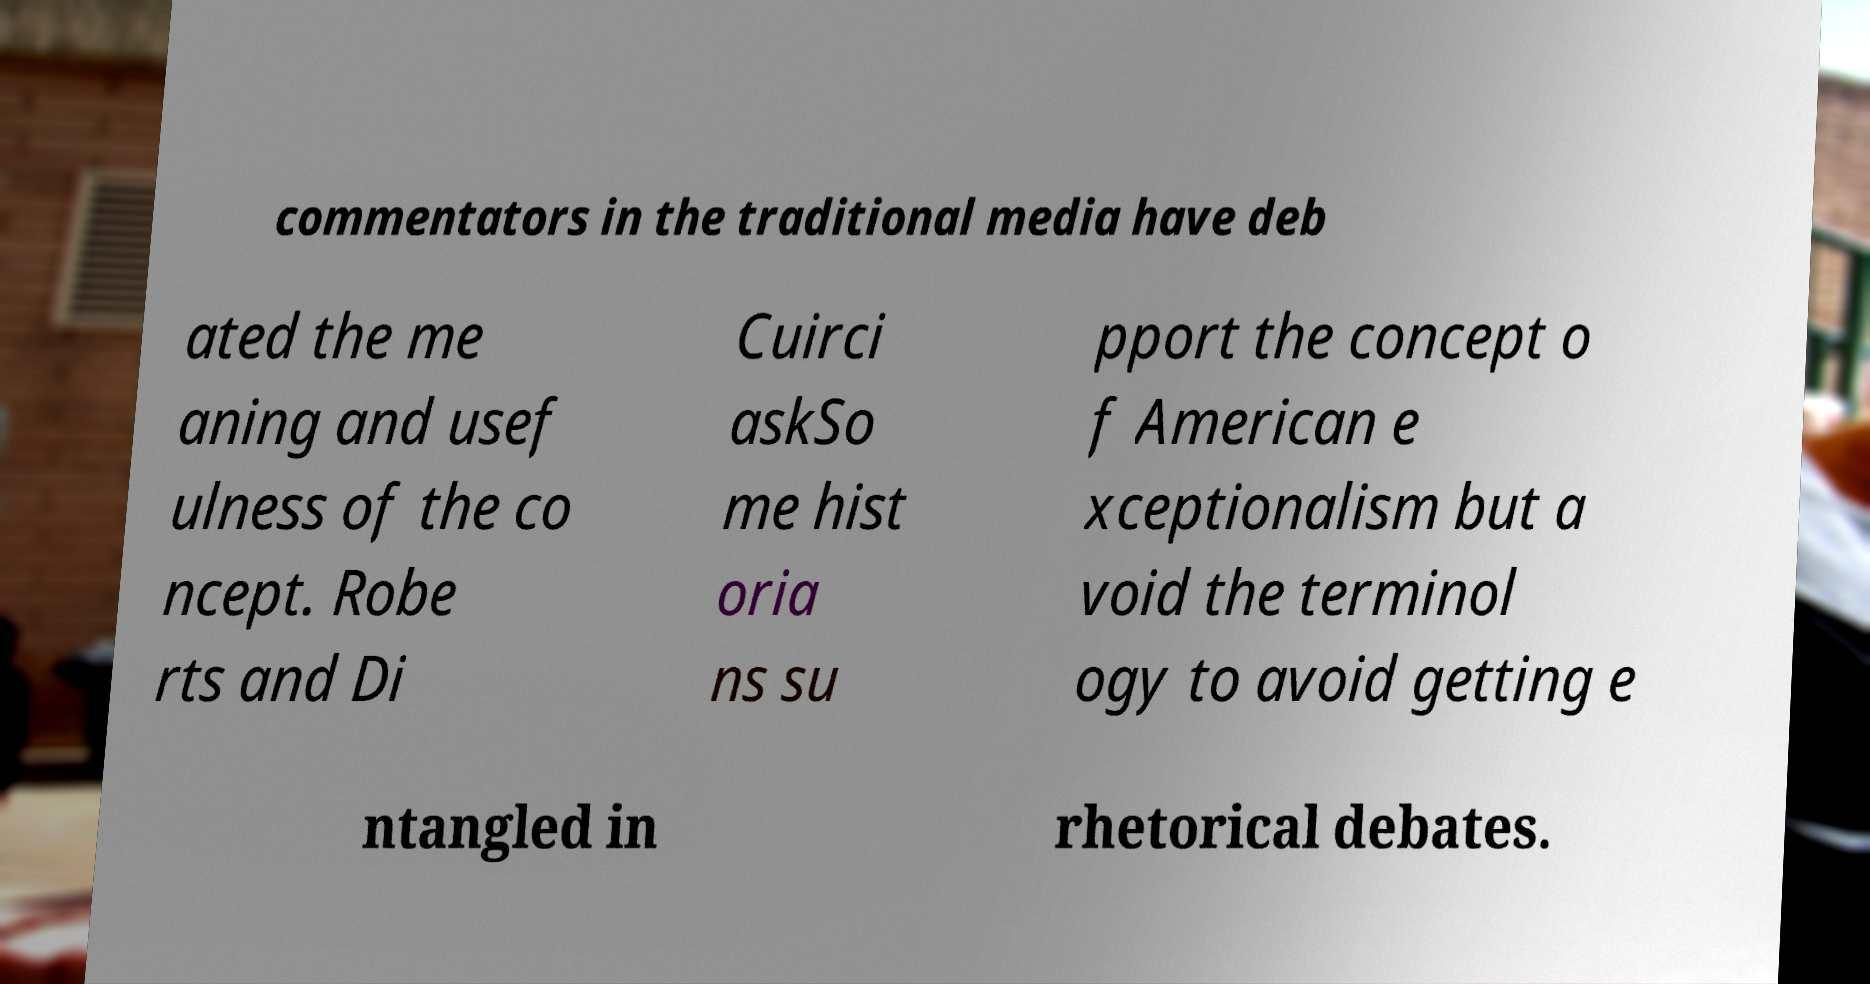Please read and relay the text visible in this image. What does it say? commentators in the traditional media have deb ated the me aning and usef ulness of the co ncept. Robe rts and Di Cuirci askSo me hist oria ns su pport the concept o f American e xceptionalism but a void the terminol ogy to avoid getting e ntangled in rhetorical debates. 